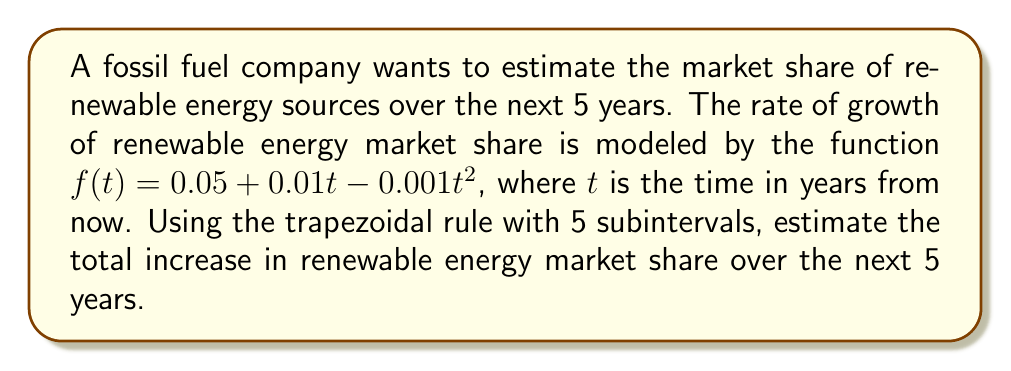Help me with this question. To solve this problem, we'll use the trapezoidal rule for numerical integration:

1) The integral we need to approximate is:
   $$\int_0^5 (0.05 + 0.01t - 0.001t^2) dt$$

2) For the trapezoidal rule with 5 subintervals, we need to calculate:
   $$\Delta t = \frac{b-a}{n} = \frac{5-0}{5} = 1$$

3) We need to evaluate $f(t)$ at $t = 0, 1, 2, 3, 4, 5$:
   $f(0) = 0.05 + 0.01(0) - 0.001(0)^2 = 0.05$
   $f(1) = 0.05 + 0.01(1) - 0.001(1)^2 = 0.059$
   $f(2) = 0.05 + 0.01(2) - 0.001(2)^2 = 0.066$
   $f(3) = 0.05 + 0.01(3) - 0.001(3)^2 = 0.071$
   $f(4) = 0.05 + 0.01(4) - 0.001(4)^2 = 0.074$
   $f(5) = 0.05 + 0.01(5) - 0.001(5)^2 = 0.075$

4) Apply the trapezoidal rule:
   $$\int_0^5 f(t)dt \approx \frac{\Delta t}{2}[f(0) + 2f(1) + 2f(2) + 2f(3) + 2f(4) + f(5)]$$
   $$= \frac{1}{2}[0.05 + 2(0.059) + 2(0.066) + 2(0.071) + 2(0.074) + 0.075]$$
   $$= \frac{1}{2}[0.05 + 0.118 + 0.132 + 0.142 + 0.148 + 0.075]$$
   $$= \frac{1}{2}[0.665] = 0.3325$$

5) This result represents the estimated total increase in renewable energy market share over the next 5 years.
Answer: 0.3325 or 33.25% 